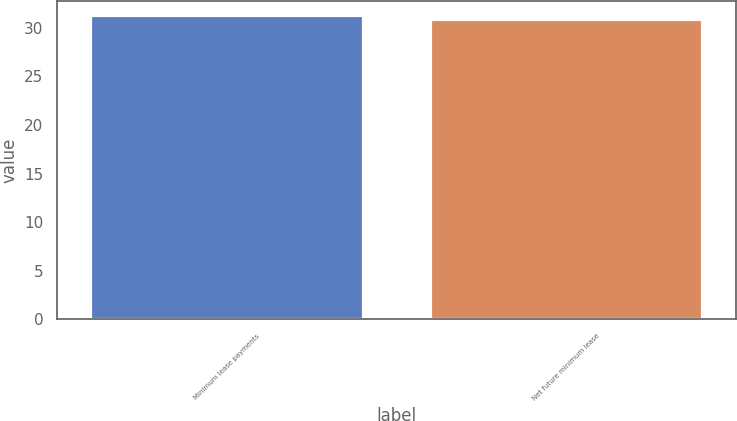Convert chart. <chart><loc_0><loc_0><loc_500><loc_500><bar_chart><fcel>Minimum lease payments<fcel>Net future minimum lease<nl><fcel>31.2<fcel>30.8<nl></chart> 